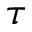<formula> <loc_0><loc_0><loc_500><loc_500>\tau</formula> 